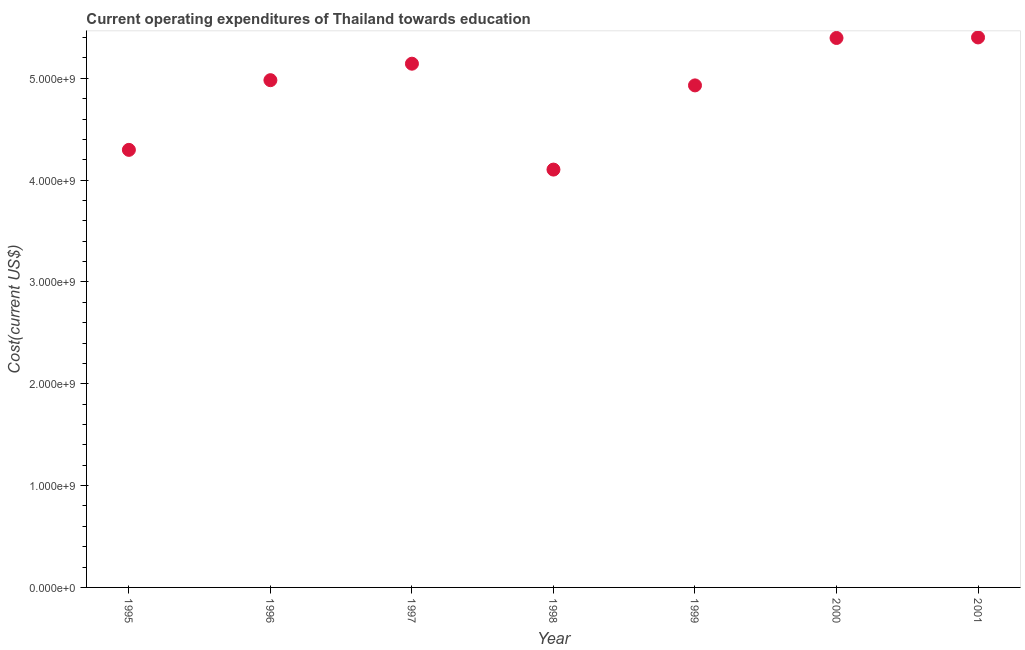What is the education expenditure in 1996?
Provide a succinct answer. 4.98e+09. Across all years, what is the maximum education expenditure?
Offer a terse response. 5.40e+09. Across all years, what is the minimum education expenditure?
Provide a succinct answer. 4.10e+09. In which year was the education expenditure maximum?
Ensure brevity in your answer.  2001. In which year was the education expenditure minimum?
Keep it short and to the point. 1998. What is the sum of the education expenditure?
Offer a very short reply. 3.43e+1. What is the difference between the education expenditure in 1997 and 2001?
Provide a short and direct response. -2.58e+08. What is the average education expenditure per year?
Give a very brief answer. 4.89e+09. What is the median education expenditure?
Your answer should be compact. 4.98e+09. In how many years, is the education expenditure greater than 2400000000 US$?
Offer a terse response. 7. What is the ratio of the education expenditure in 1995 to that in 2000?
Your answer should be compact. 0.8. Is the education expenditure in 1996 less than that in 1998?
Provide a short and direct response. No. What is the difference between the highest and the second highest education expenditure?
Your answer should be very brief. 5.35e+06. Is the sum of the education expenditure in 1998 and 2000 greater than the maximum education expenditure across all years?
Keep it short and to the point. Yes. What is the difference between the highest and the lowest education expenditure?
Your response must be concise. 1.30e+09. How many dotlines are there?
Make the answer very short. 1. How many years are there in the graph?
Keep it short and to the point. 7. Are the values on the major ticks of Y-axis written in scientific E-notation?
Offer a terse response. Yes. Does the graph contain any zero values?
Provide a short and direct response. No. What is the title of the graph?
Keep it short and to the point. Current operating expenditures of Thailand towards education. What is the label or title of the X-axis?
Your answer should be compact. Year. What is the label or title of the Y-axis?
Keep it short and to the point. Cost(current US$). What is the Cost(current US$) in 1995?
Offer a terse response. 4.30e+09. What is the Cost(current US$) in 1996?
Ensure brevity in your answer.  4.98e+09. What is the Cost(current US$) in 1997?
Your answer should be very brief. 5.14e+09. What is the Cost(current US$) in 1998?
Give a very brief answer. 4.10e+09. What is the Cost(current US$) in 1999?
Your answer should be very brief. 4.93e+09. What is the Cost(current US$) in 2000?
Your answer should be very brief. 5.40e+09. What is the Cost(current US$) in 2001?
Keep it short and to the point. 5.40e+09. What is the difference between the Cost(current US$) in 1995 and 1996?
Your response must be concise. -6.84e+08. What is the difference between the Cost(current US$) in 1995 and 1997?
Provide a short and direct response. -8.46e+08. What is the difference between the Cost(current US$) in 1995 and 1998?
Your answer should be very brief. 1.94e+08. What is the difference between the Cost(current US$) in 1995 and 1999?
Provide a succinct answer. -6.33e+08. What is the difference between the Cost(current US$) in 1995 and 2000?
Provide a short and direct response. -1.10e+09. What is the difference between the Cost(current US$) in 1995 and 2001?
Provide a short and direct response. -1.10e+09. What is the difference between the Cost(current US$) in 1996 and 1997?
Provide a succinct answer. -1.62e+08. What is the difference between the Cost(current US$) in 1996 and 1998?
Provide a short and direct response. 8.78e+08. What is the difference between the Cost(current US$) in 1996 and 1999?
Make the answer very short. 5.12e+07. What is the difference between the Cost(current US$) in 1996 and 2000?
Your answer should be very brief. -4.14e+08. What is the difference between the Cost(current US$) in 1996 and 2001?
Your response must be concise. -4.20e+08. What is the difference between the Cost(current US$) in 1997 and 1998?
Provide a short and direct response. 1.04e+09. What is the difference between the Cost(current US$) in 1997 and 1999?
Your answer should be very brief. 2.13e+08. What is the difference between the Cost(current US$) in 1997 and 2000?
Give a very brief answer. -2.53e+08. What is the difference between the Cost(current US$) in 1997 and 2001?
Your response must be concise. -2.58e+08. What is the difference between the Cost(current US$) in 1998 and 1999?
Your response must be concise. -8.27e+08. What is the difference between the Cost(current US$) in 1998 and 2000?
Keep it short and to the point. -1.29e+09. What is the difference between the Cost(current US$) in 1998 and 2001?
Give a very brief answer. -1.30e+09. What is the difference between the Cost(current US$) in 1999 and 2000?
Provide a succinct answer. -4.66e+08. What is the difference between the Cost(current US$) in 1999 and 2001?
Offer a terse response. -4.71e+08. What is the difference between the Cost(current US$) in 2000 and 2001?
Keep it short and to the point. -5.35e+06. What is the ratio of the Cost(current US$) in 1995 to that in 1996?
Your answer should be very brief. 0.86. What is the ratio of the Cost(current US$) in 1995 to that in 1997?
Offer a very short reply. 0.83. What is the ratio of the Cost(current US$) in 1995 to that in 1998?
Offer a terse response. 1.05. What is the ratio of the Cost(current US$) in 1995 to that in 1999?
Provide a succinct answer. 0.87. What is the ratio of the Cost(current US$) in 1995 to that in 2000?
Provide a succinct answer. 0.8. What is the ratio of the Cost(current US$) in 1995 to that in 2001?
Your response must be concise. 0.8. What is the ratio of the Cost(current US$) in 1996 to that in 1998?
Your answer should be very brief. 1.21. What is the ratio of the Cost(current US$) in 1996 to that in 2000?
Provide a short and direct response. 0.92. What is the ratio of the Cost(current US$) in 1996 to that in 2001?
Offer a terse response. 0.92. What is the ratio of the Cost(current US$) in 1997 to that in 1998?
Offer a very short reply. 1.25. What is the ratio of the Cost(current US$) in 1997 to that in 1999?
Make the answer very short. 1.04. What is the ratio of the Cost(current US$) in 1997 to that in 2000?
Give a very brief answer. 0.95. What is the ratio of the Cost(current US$) in 1997 to that in 2001?
Your response must be concise. 0.95. What is the ratio of the Cost(current US$) in 1998 to that in 1999?
Ensure brevity in your answer.  0.83. What is the ratio of the Cost(current US$) in 1998 to that in 2000?
Offer a very short reply. 0.76. What is the ratio of the Cost(current US$) in 1998 to that in 2001?
Your response must be concise. 0.76. What is the ratio of the Cost(current US$) in 1999 to that in 2000?
Provide a short and direct response. 0.91. 